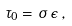Convert formula to latex. <formula><loc_0><loc_0><loc_500><loc_500>\tau _ { 0 } = \sigma \, \epsilon \, ,</formula> 